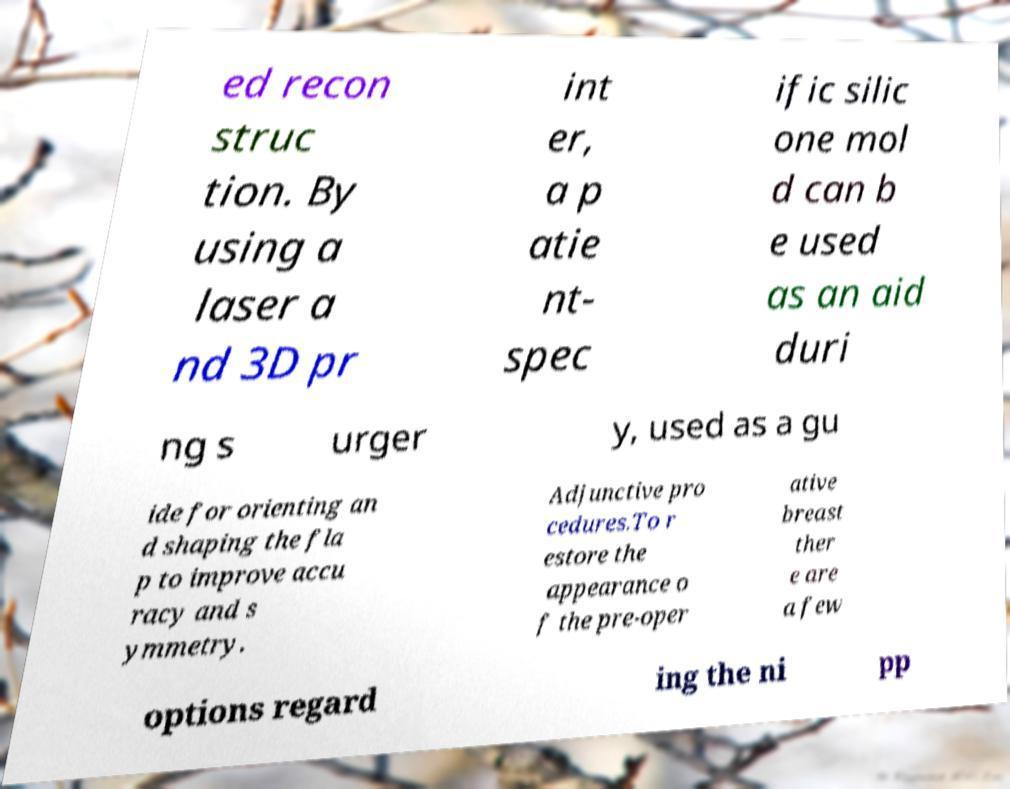Could you assist in decoding the text presented in this image and type it out clearly? ed recon struc tion. By using a laser a nd 3D pr int er, a p atie nt- spec ific silic one mol d can b e used as an aid duri ng s urger y, used as a gu ide for orienting an d shaping the fla p to improve accu racy and s ymmetry. Adjunctive pro cedures.To r estore the appearance o f the pre-oper ative breast ther e are a few options regard ing the ni pp 